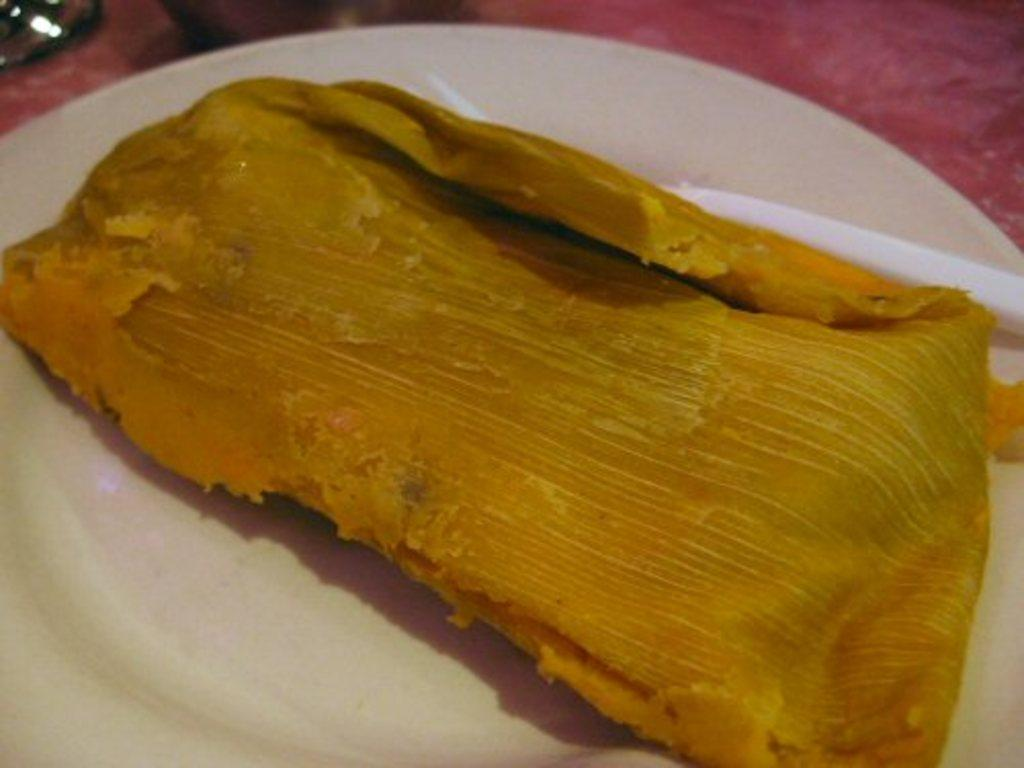What piece of furniture is present in the image? There is a table in the image. What is placed on the table? There is a plate on the table. What can be found on the plate? There is a food item on the plate. What is the name of the bear that is sitting on the plate in the image? There are no bears present in the image; it only features a table, a plate, and a food item. 